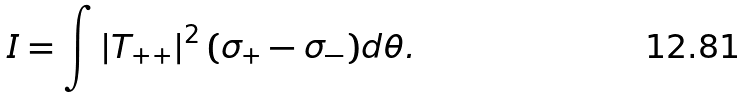<formula> <loc_0><loc_0><loc_500><loc_500>I = \int \left | T _ { + + } \right | ^ { 2 } ( \sigma _ { + } - \sigma _ { - } ) d \theta .</formula> 